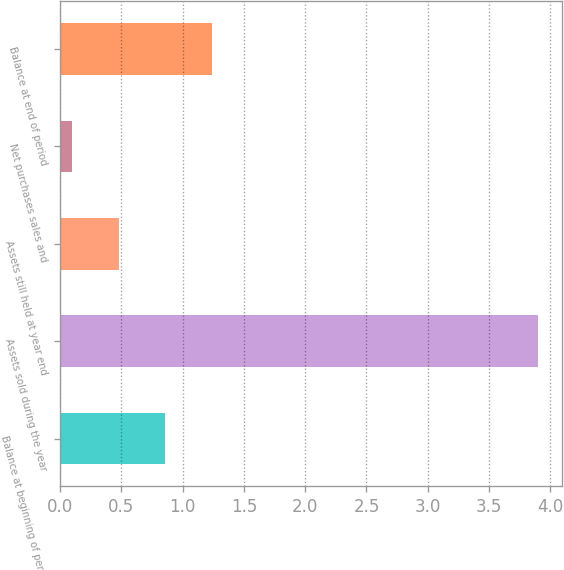Convert chart to OTSL. <chart><loc_0><loc_0><loc_500><loc_500><bar_chart><fcel>Balance at beginning of period<fcel>Assets sold during the year<fcel>Assets still held at year end<fcel>Net purchases sales and<fcel>Balance at end of period<nl><fcel>0.86<fcel>3.9<fcel>0.48<fcel>0.1<fcel>1.24<nl></chart> 